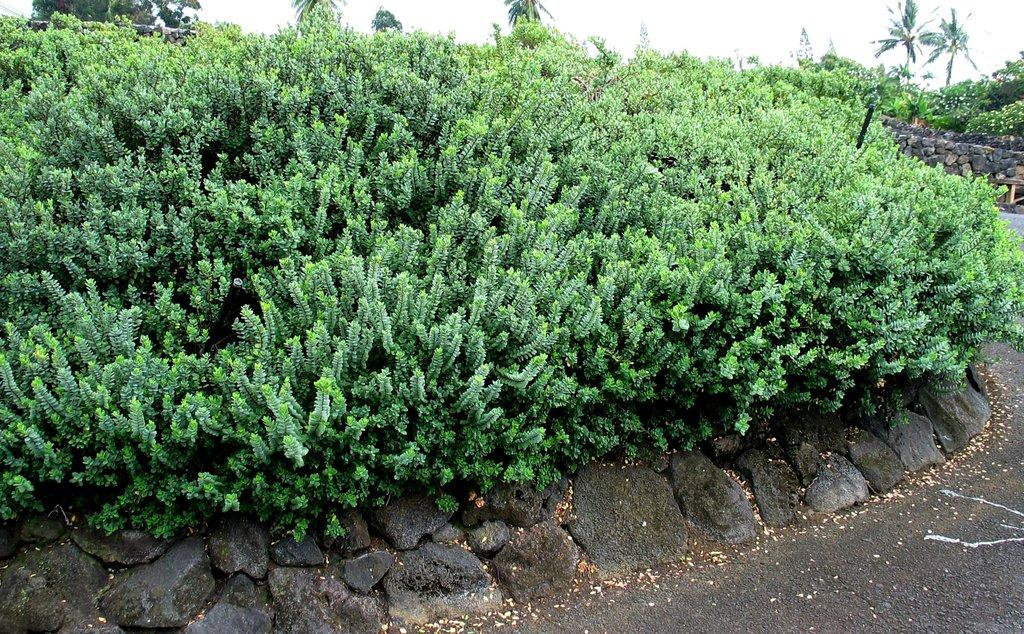What type of vegetation can be seen in the image? There are plants and trees in the image. What type of structure is present in the image? There is a rock wall in the image. What can be seen in the background of the image? The sky is visible in the background of the image. What sign of anger can be seen on the plants in the image? There is no sign of anger on the plants in the image, as plants do not exhibit emotions like anger. 